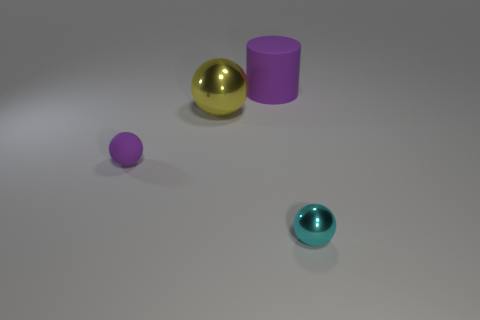Subtract all yellow metallic balls. How many balls are left? 2 Add 2 tiny brown shiny things. How many objects exist? 6 Subtract 1 cylinders. How many cylinders are left? 0 Subtract all purple balls. How many balls are left? 2 Subtract 0 brown spheres. How many objects are left? 4 Subtract all cylinders. How many objects are left? 3 Subtract all green spheres. Subtract all yellow blocks. How many spheres are left? 3 Subtract all brown cylinders. How many green spheres are left? 0 Subtract all big purple cylinders. Subtract all yellow metal spheres. How many objects are left? 2 Add 3 purple things. How many purple things are left? 5 